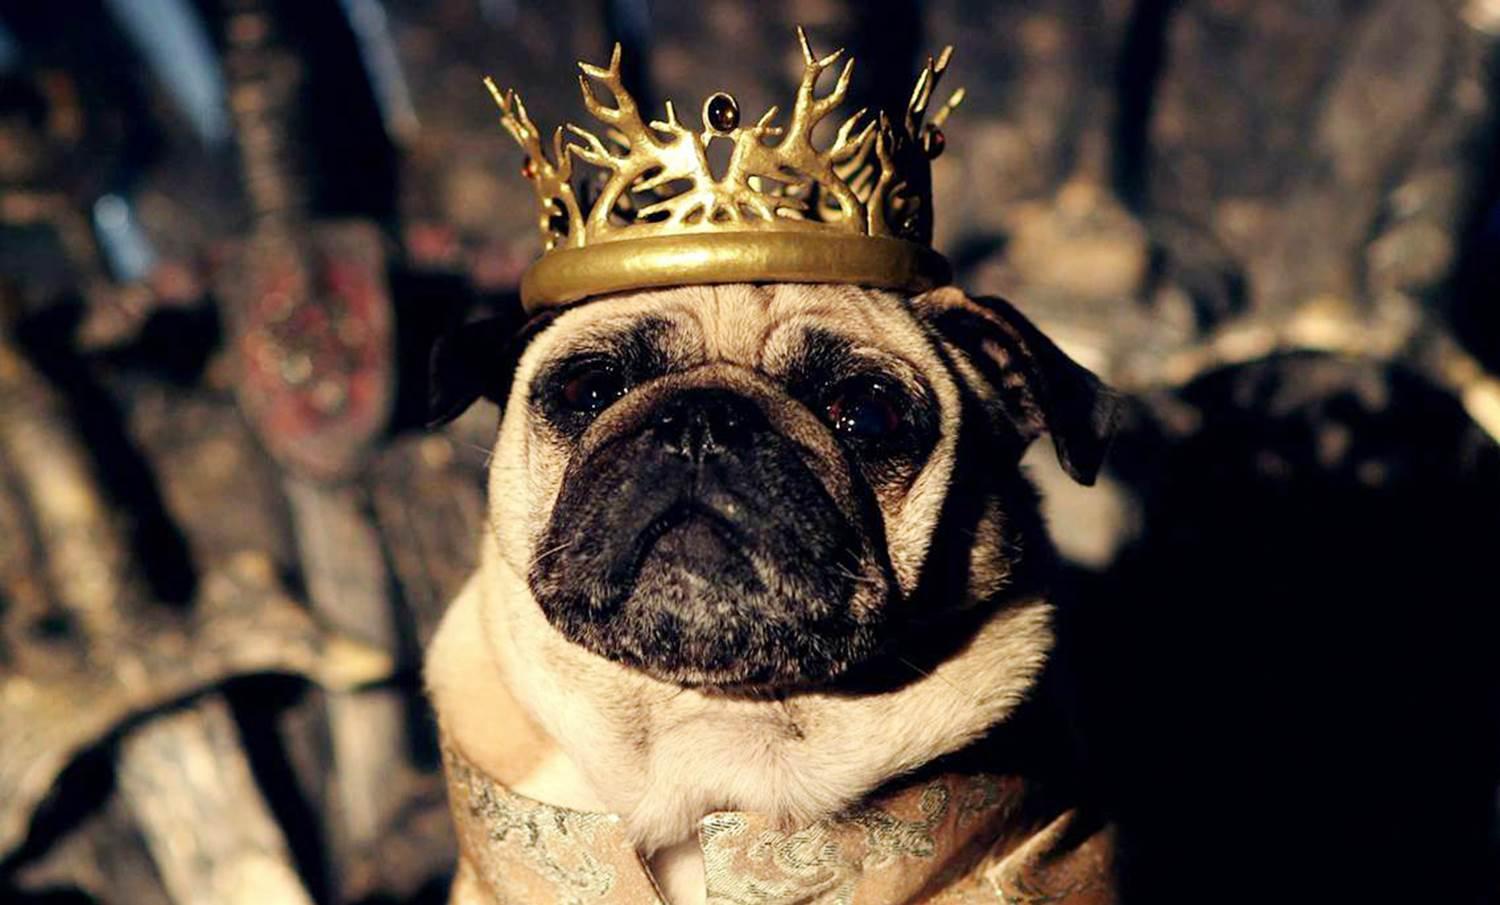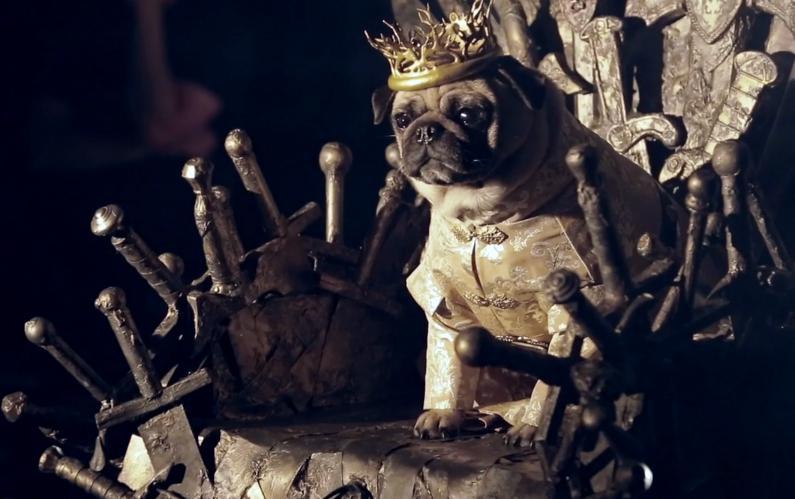The first image is the image on the left, the second image is the image on the right. For the images shown, is this caption "Three small dogs stand next to each other dressed in costume." true? Answer yes or no. No. The first image is the image on the left, the second image is the image on the right. Considering the images on both sides, is "There are at least four dressed up pugs." valid? Answer yes or no. No. 